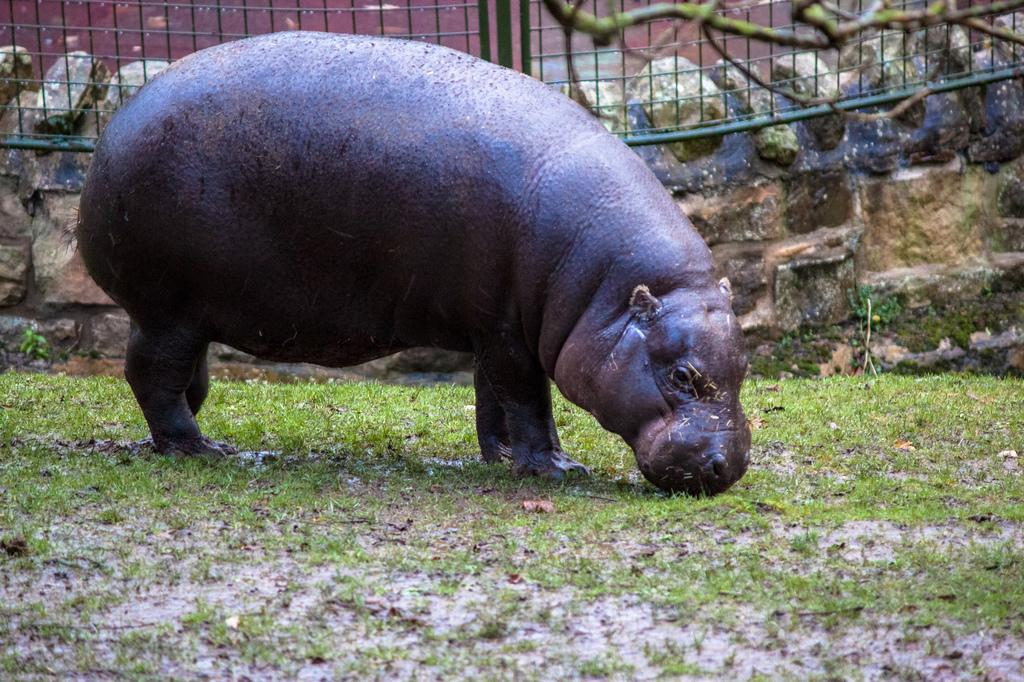What type of animal can be seen in the image? There is an animal in the image, but its specific type cannot be determined from the provided facts. Where is the animal located in the image? The animal is on the ground in the image. What type of vegetation is present on the ground in the image? There is grass on the ground in the image. What structures can be seen in the image? There is a wall and fencing in the image. Can you describe the object on the top right side of the image? Unfortunately, the provided facts do not give enough information to describe the object on the top right side of the image. What type of locket is the hen wearing in the image? There is no hen or locket present in the image. How many people are attending the party in the image? There is no party depicted in the image. 